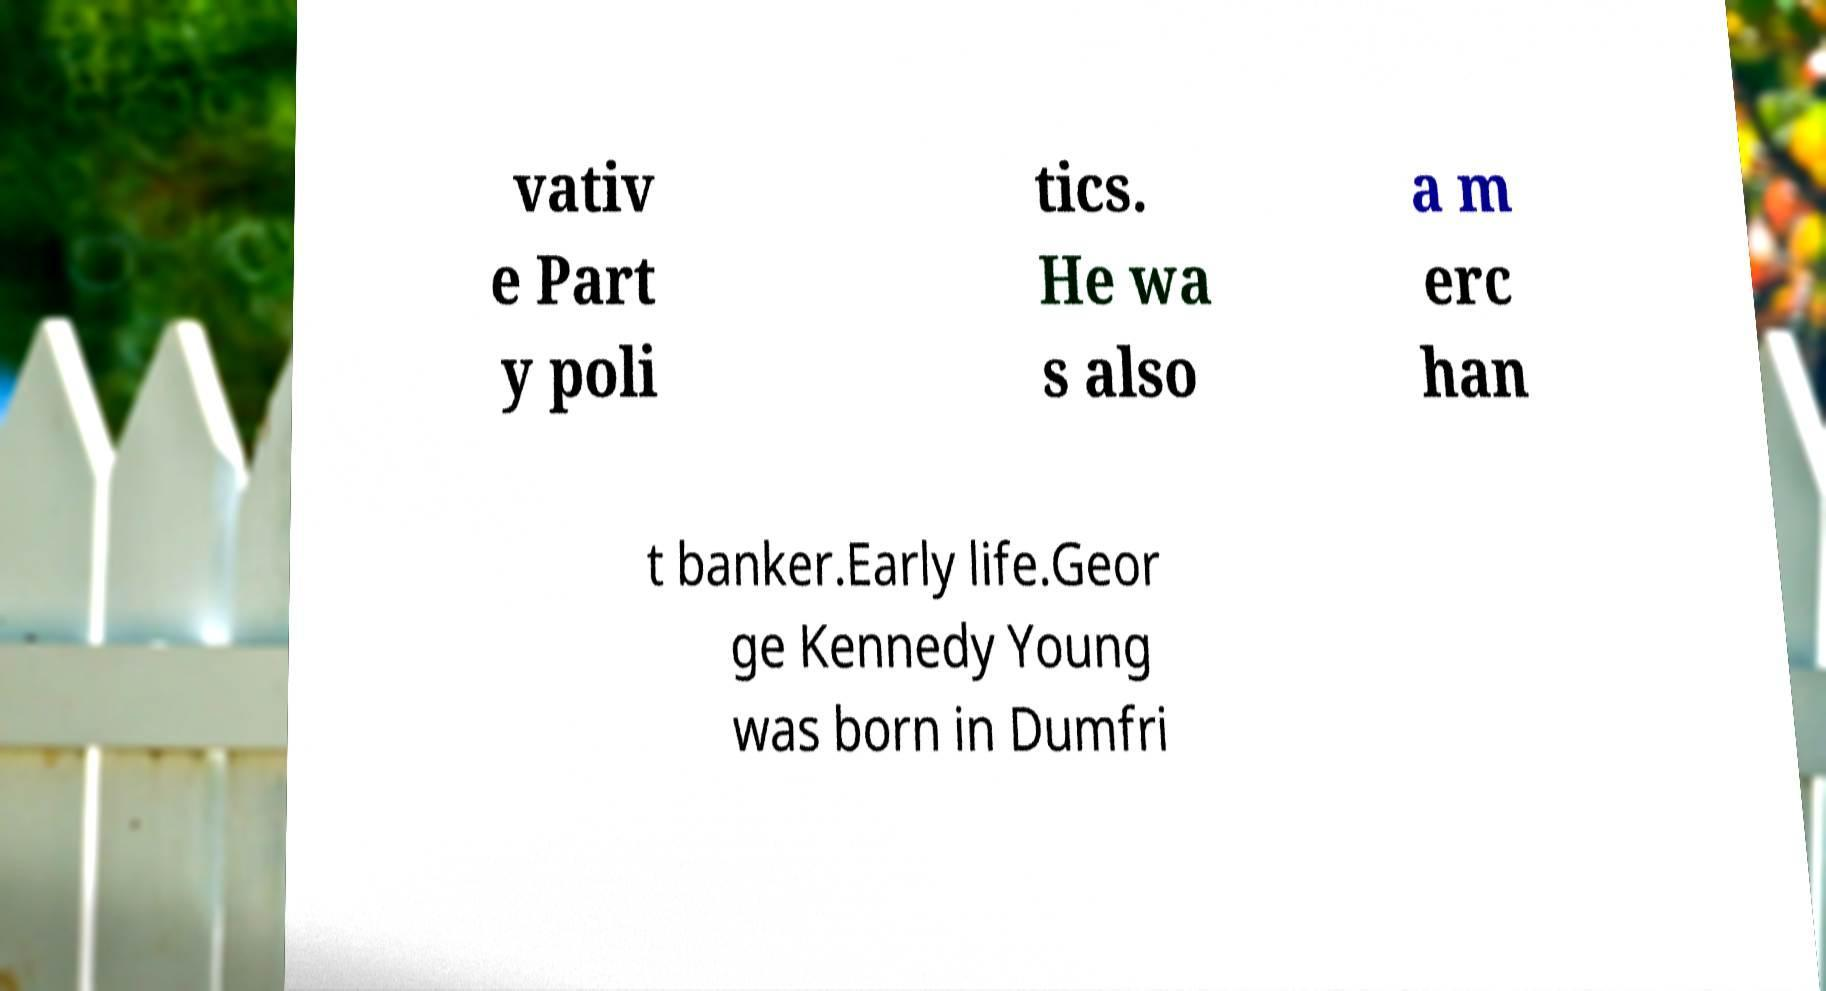There's text embedded in this image that I need extracted. Can you transcribe it verbatim? vativ e Part y poli tics. He wa s also a m erc han t banker.Early life.Geor ge Kennedy Young was born in Dumfri 